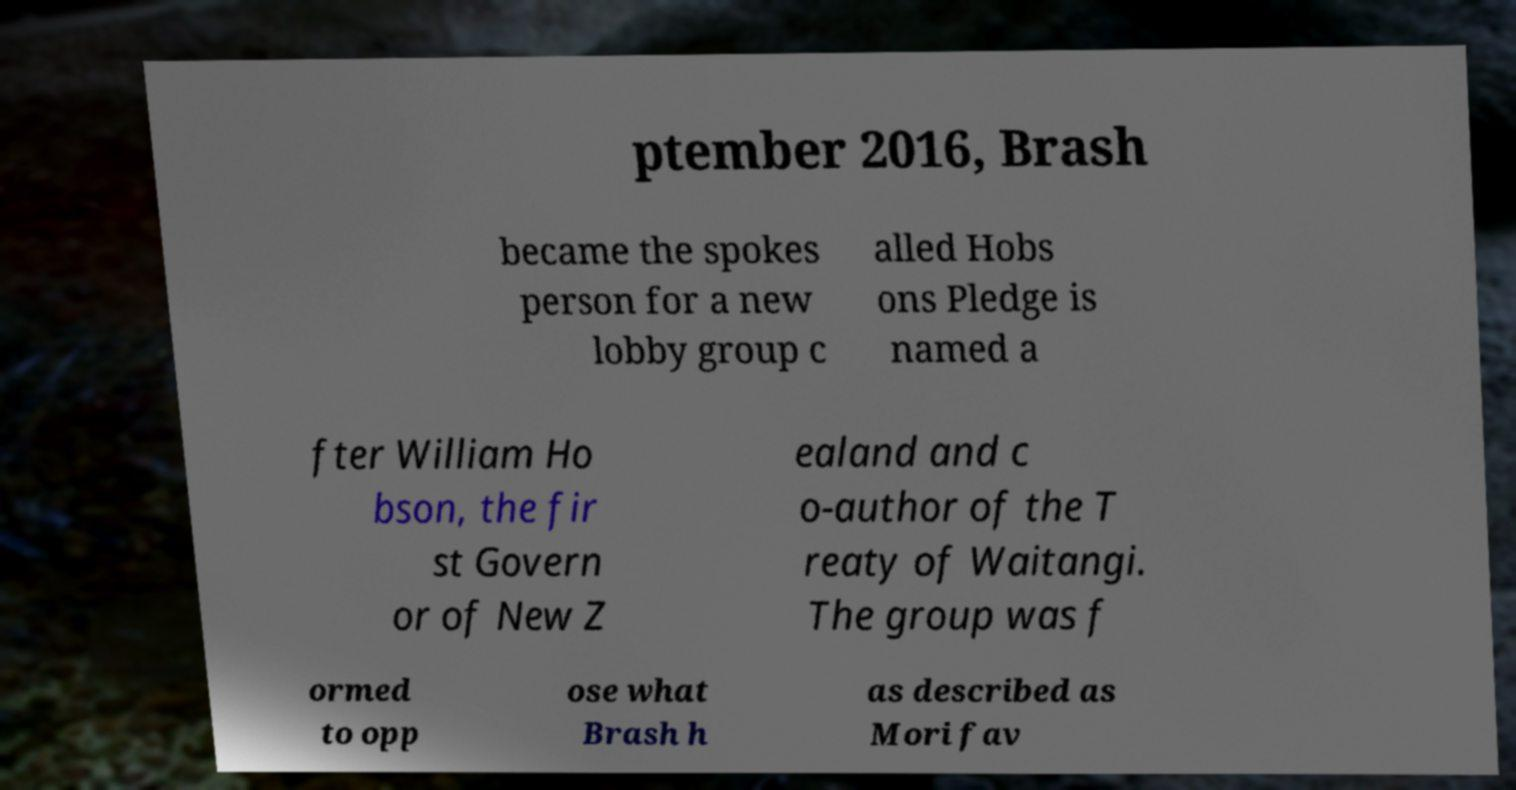Can you read and provide the text displayed in the image?This photo seems to have some interesting text. Can you extract and type it out for me? ptember 2016, Brash became the spokes person for a new lobby group c alled Hobs ons Pledge is named a fter William Ho bson, the fir st Govern or of New Z ealand and c o-author of the T reaty of Waitangi. The group was f ormed to opp ose what Brash h as described as Mori fav 